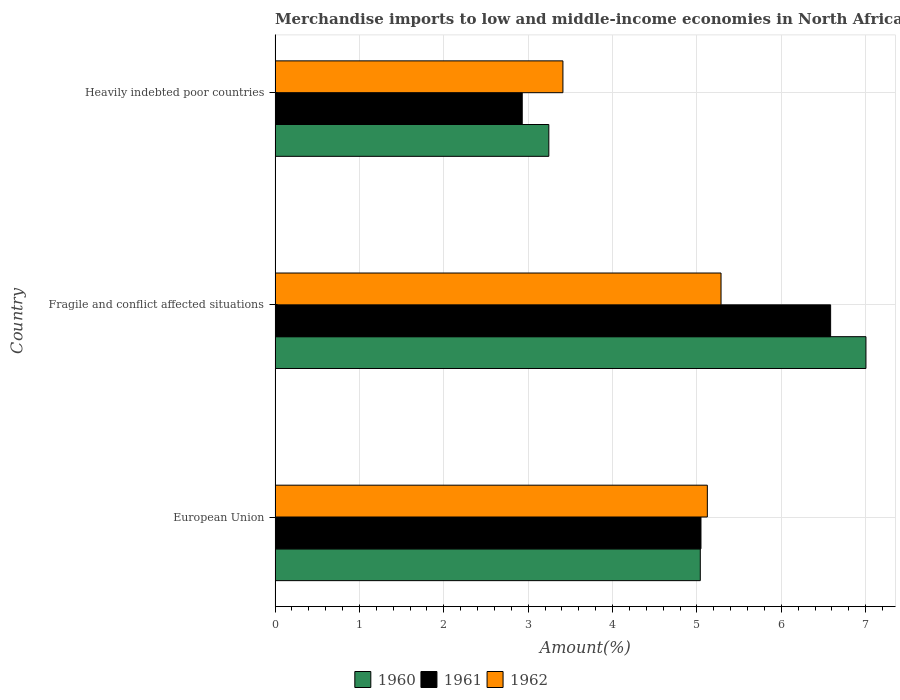How many bars are there on the 1st tick from the bottom?
Your answer should be very brief. 3. In how many cases, is the number of bars for a given country not equal to the number of legend labels?
Your answer should be very brief. 0. What is the percentage of amount earned from merchandise imports in 1961 in Heavily indebted poor countries?
Offer a terse response. 2.93. Across all countries, what is the maximum percentage of amount earned from merchandise imports in 1961?
Offer a terse response. 6.58. Across all countries, what is the minimum percentage of amount earned from merchandise imports in 1960?
Your response must be concise. 3.24. In which country was the percentage of amount earned from merchandise imports in 1962 maximum?
Ensure brevity in your answer.  Fragile and conflict affected situations. In which country was the percentage of amount earned from merchandise imports in 1961 minimum?
Offer a very short reply. Heavily indebted poor countries. What is the total percentage of amount earned from merchandise imports in 1960 in the graph?
Keep it short and to the point. 15.29. What is the difference between the percentage of amount earned from merchandise imports in 1961 in European Union and that in Heavily indebted poor countries?
Provide a short and direct response. 2.12. What is the difference between the percentage of amount earned from merchandise imports in 1962 in Heavily indebted poor countries and the percentage of amount earned from merchandise imports in 1961 in European Union?
Offer a terse response. -1.64. What is the average percentage of amount earned from merchandise imports in 1960 per country?
Make the answer very short. 5.1. What is the difference between the percentage of amount earned from merchandise imports in 1962 and percentage of amount earned from merchandise imports in 1960 in Fragile and conflict affected situations?
Ensure brevity in your answer.  -1.72. What is the ratio of the percentage of amount earned from merchandise imports in 1962 in European Union to that in Heavily indebted poor countries?
Ensure brevity in your answer.  1.5. Is the percentage of amount earned from merchandise imports in 1961 in European Union less than that in Fragile and conflict affected situations?
Provide a short and direct response. Yes. What is the difference between the highest and the second highest percentage of amount earned from merchandise imports in 1961?
Ensure brevity in your answer.  1.54. What is the difference between the highest and the lowest percentage of amount earned from merchandise imports in 1961?
Your response must be concise. 3.66. In how many countries, is the percentage of amount earned from merchandise imports in 1960 greater than the average percentage of amount earned from merchandise imports in 1960 taken over all countries?
Your answer should be very brief. 1. What does the 2nd bar from the top in Heavily indebted poor countries represents?
Offer a terse response. 1961. Is it the case that in every country, the sum of the percentage of amount earned from merchandise imports in 1961 and percentage of amount earned from merchandise imports in 1960 is greater than the percentage of amount earned from merchandise imports in 1962?
Give a very brief answer. Yes. How many bars are there?
Ensure brevity in your answer.  9. How many countries are there in the graph?
Give a very brief answer. 3. Are the values on the major ticks of X-axis written in scientific E-notation?
Offer a very short reply. No. Does the graph contain grids?
Give a very brief answer. Yes. What is the title of the graph?
Make the answer very short. Merchandise imports to low and middle-income economies in North Africa. What is the label or title of the X-axis?
Offer a terse response. Amount(%). What is the label or title of the Y-axis?
Give a very brief answer. Country. What is the Amount(%) of 1960 in European Union?
Offer a terse response. 5.04. What is the Amount(%) of 1961 in European Union?
Your response must be concise. 5.05. What is the Amount(%) of 1962 in European Union?
Your answer should be very brief. 5.12. What is the Amount(%) of 1960 in Fragile and conflict affected situations?
Give a very brief answer. 7. What is the Amount(%) in 1961 in Fragile and conflict affected situations?
Offer a very short reply. 6.58. What is the Amount(%) in 1962 in Fragile and conflict affected situations?
Make the answer very short. 5.29. What is the Amount(%) in 1960 in Heavily indebted poor countries?
Provide a short and direct response. 3.24. What is the Amount(%) in 1961 in Heavily indebted poor countries?
Provide a succinct answer. 2.93. What is the Amount(%) in 1962 in Heavily indebted poor countries?
Offer a terse response. 3.41. Across all countries, what is the maximum Amount(%) of 1960?
Make the answer very short. 7. Across all countries, what is the maximum Amount(%) of 1961?
Your answer should be compact. 6.58. Across all countries, what is the maximum Amount(%) in 1962?
Your answer should be compact. 5.29. Across all countries, what is the minimum Amount(%) of 1960?
Keep it short and to the point. 3.24. Across all countries, what is the minimum Amount(%) in 1961?
Your response must be concise. 2.93. Across all countries, what is the minimum Amount(%) in 1962?
Your answer should be very brief. 3.41. What is the total Amount(%) of 1960 in the graph?
Make the answer very short. 15.29. What is the total Amount(%) of 1961 in the graph?
Give a very brief answer. 14.56. What is the total Amount(%) of 1962 in the graph?
Give a very brief answer. 13.82. What is the difference between the Amount(%) in 1960 in European Union and that in Fragile and conflict affected situations?
Offer a terse response. -1.96. What is the difference between the Amount(%) of 1961 in European Union and that in Fragile and conflict affected situations?
Keep it short and to the point. -1.54. What is the difference between the Amount(%) in 1962 in European Union and that in Fragile and conflict affected situations?
Make the answer very short. -0.16. What is the difference between the Amount(%) of 1960 in European Union and that in Heavily indebted poor countries?
Keep it short and to the point. 1.8. What is the difference between the Amount(%) in 1961 in European Union and that in Heavily indebted poor countries?
Provide a succinct answer. 2.12. What is the difference between the Amount(%) of 1962 in European Union and that in Heavily indebted poor countries?
Offer a very short reply. 1.71. What is the difference between the Amount(%) of 1960 in Fragile and conflict affected situations and that in Heavily indebted poor countries?
Your answer should be compact. 3.76. What is the difference between the Amount(%) of 1961 in Fragile and conflict affected situations and that in Heavily indebted poor countries?
Give a very brief answer. 3.66. What is the difference between the Amount(%) of 1962 in Fragile and conflict affected situations and that in Heavily indebted poor countries?
Provide a short and direct response. 1.87. What is the difference between the Amount(%) of 1960 in European Union and the Amount(%) of 1961 in Fragile and conflict affected situations?
Your response must be concise. -1.54. What is the difference between the Amount(%) in 1960 in European Union and the Amount(%) in 1962 in Fragile and conflict affected situations?
Your answer should be compact. -0.25. What is the difference between the Amount(%) of 1961 in European Union and the Amount(%) of 1962 in Fragile and conflict affected situations?
Provide a short and direct response. -0.24. What is the difference between the Amount(%) of 1960 in European Union and the Amount(%) of 1961 in Heavily indebted poor countries?
Your answer should be very brief. 2.11. What is the difference between the Amount(%) in 1960 in European Union and the Amount(%) in 1962 in Heavily indebted poor countries?
Your answer should be very brief. 1.63. What is the difference between the Amount(%) in 1961 in European Union and the Amount(%) in 1962 in Heavily indebted poor countries?
Ensure brevity in your answer.  1.64. What is the difference between the Amount(%) in 1960 in Fragile and conflict affected situations and the Amount(%) in 1961 in Heavily indebted poor countries?
Keep it short and to the point. 4.07. What is the difference between the Amount(%) in 1960 in Fragile and conflict affected situations and the Amount(%) in 1962 in Heavily indebted poor countries?
Provide a short and direct response. 3.59. What is the difference between the Amount(%) in 1961 in Fragile and conflict affected situations and the Amount(%) in 1962 in Heavily indebted poor countries?
Give a very brief answer. 3.17. What is the average Amount(%) of 1960 per country?
Make the answer very short. 5.1. What is the average Amount(%) of 1961 per country?
Your answer should be very brief. 4.85. What is the average Amount(%) in 1962 per country?
Your response must be concise. 4.61. What is the difference between the Amount(%) of 1960 and Amount(%) of 1961 in European Union?
Your response must be concise. -0.01. What is the difference between the Amount(%) in 1960 and Amount(%) in 1962 in European Union?
Offer a very short reply. -0.08. What is the difference between the Amount(%) in 1961 and Amount(%) in 1962 in European Union?
Keep it short and to the point. -0.08. What is the difference between the Amount(%) of 1960 and Amount(%) of 1961 in Fragile and conflict affected situations?
Your response must be concise. 0.42. What is the difference between the Amount(%) of 1960 and Amount(%) of 1962 in Fragile and conflict affected situations?
Give a very brief answer. 1.72. What is the difference between the Amount(%) of 1961 and Amount(%) of 1962 in Fragile and conflict affected situations?
Keep it short and to the point. 1.3. What is the difference between the Amount(%) in 1960 and Amount(%) in 1961 in Heavily indebted poor countries?
Offer a terse response. 0.32. What is the difference between the Amount(%) in 1960 and Amount(%) in 1962 in Heavily indebted poor countries?
Your answer should be compact. -0.17. What is the difference between the Amount(%) in 1961 and Amount(%) in 1962 in Heavily indebted poor countries?
Offer a very short reply. -0.48. What is the ratio of the Amount(%) in 1960 in European Union to that in Fragile and conflict affected situations?
Your response must be concise. 0.72. What is the ratio of the Amount(%) of 1961 in European Union to that in Fragile and conflict affected situations?
Provide a succinct answer. 0.77. What is the ratio of the Amount(%) of 1962 in European Union to that in Fragile and conflict affected situations?
Your answer should be compact. 0.97. What is the ratio of the Amount(%) in 1960 in European Union to that in Heavily indebted poor countries?
Your response must be concise. 1.55. What is the ratio of the Amount(%) in 1961 in European Union to that in Heavily indebted poor countries?
Provide a succinct answer. 1.72. What is the ratio of the Amount(%) in 1962 in European Union to that in Heavily indebted poor countries?
Make the answer very short. 1.5. What is the ratio of the Amount(%) of 1960 in Fragile and conflict affected situations to that in Heavily indebted poor countries?
Your answer should be very brief. 2.16. What is the ratio of the Amount(%) in 1961 in Fragile and conflict affected situations to that in Heavily indebted poor countries?
Your answer should be compact. 2.25. What is the ratio of the Amount(%) of 1962 in Fragile and conflict affected situations to that in Heavily indebted poor countries?
Ensure brevity in your answer.  1.55. What is the difference between the highest and the second highest Amount(%) of 1960?
Offer a very short reply. 1.96. What is the difference between the highest and the second highest Amount(%) of 1961?
Keep it short and to the point. 1.54. What is the difference between the highest and the second highest Amount(%) of 1962?
Your response must be concise. 0.16. What is the difference between the highest and the lowest Amount(%) of 1960?
Your response must be concise. 3.76. What is the difference between the highest and the lowest Amount(%) of 1961?
Offer a very short reply. 3.66. What is the difference between the highest and the lowest Amount(%) of 1962?
Make the answer very short. 1.87. 